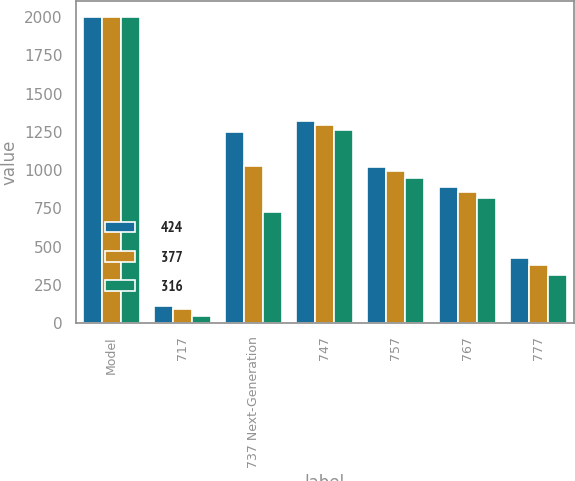Convert chart. <chart><loc_0><loc_0><loc_500><loc_500><stacked_bar_chart><ecel><fcel>Model<fcel>717<fcel>737 Next-Generation<fcel>747<fcel>757<fcel>767<fcel>777<nl><fcel>424<fcel>2002<fcel>113<fcel>1247<fcel>1319<fcel>1022<fcel>892<fcel>424<nl><fcel>377<fcel>2001<fcel>93<fcel>1024<fcel>1292<fcel>993<fcel>857<fcel>377<nl><fcel>316<fcel>2000<fcel>44<fcel>725<fcel>1261<fcel>948<fcel>817<fcel>316<nl></chart> 